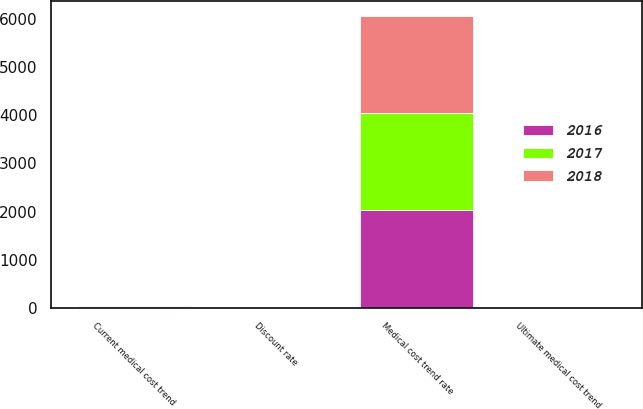Convert chart. <chart><loc_0><loc_0><loc_500><loc_500><stacked_bar_chart><ecel><fcel>Discount rate<fcel>Current medical cost trend<fcel>Ultimate medical cost trend<fcel>Medical cost trend rate<nl><fcel>2017<fcel>3.46<fcel>9.79<fcel>4.5<fcel>2025<nl><fcel>2016<fcel>3.15<fcel>8.68<fcel>4.5<fcel>2025<nl><fcel>2018<fcel>3.96<fcel>9<fcel>4.5<fcel>2025<nl></chart> 